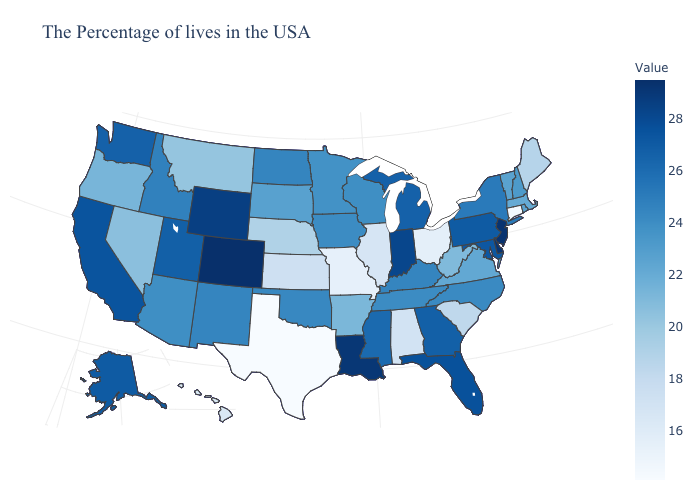Does Nevada have a lower value than Kansas?
Quick response, please. No. Which states have the lowest value in the Northeast?
Keep it brief. Connecticut. Which states have the lowest value in the USA?
Give a very brief answer. Texas. Among the states that border Virginia , which have the lowest value?
Keep it brief. West Virginia. 